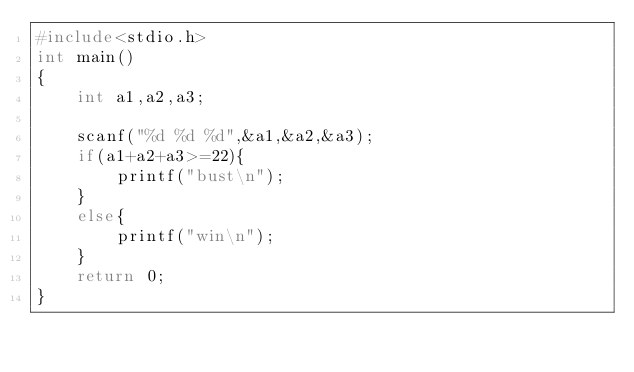<code> <loc_0><loc_0><loc_500><loc_500><_C_>#include<stdio.h>
int main()
{
    int a1,a2,a3;

    scanf("%d %d %d",&a1,&a2,&a3);
    if(a1+a2+a3>=22){
        printf("bust\n");
    }
    else{
        printf("win\n");
    }
    return 0;
}</code> 